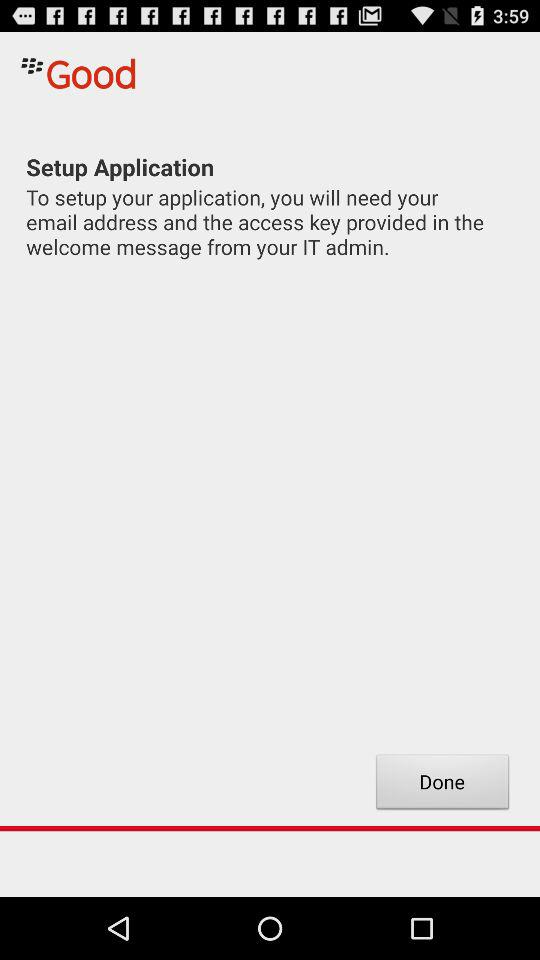What is the name of application? The name of the application is "Good". 